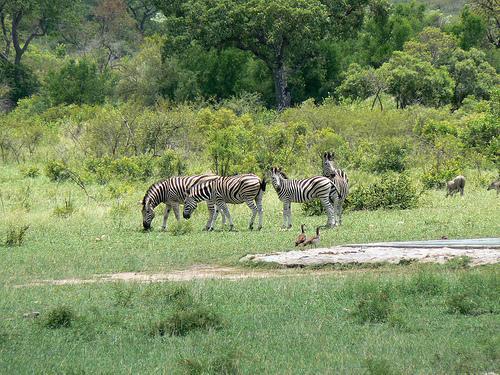How many zebra are there?
Give a very brief answer. 4. 